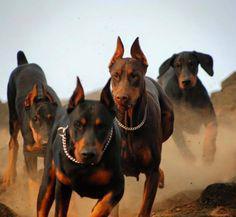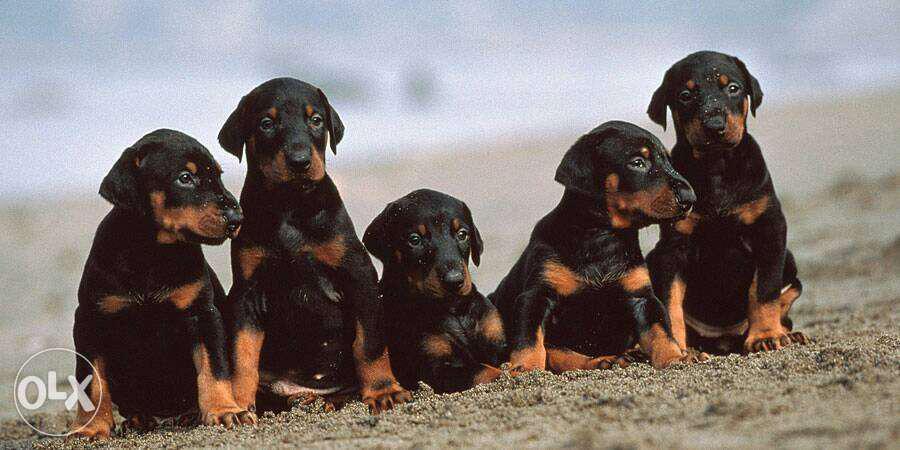The first image is the image on the left, the second image is the image on the right. For the images displayed, is the sentence "The right image contains exactly five dogs." factually correct? Answer yes or no. Yes. The first image is the image on the left, the second image is the image on the right. For the images displayed, is the sentence "All dogs are pointy-eared adult dobermans, and at least seven dogs in total are shown." factually correct? Answer yes or no. No. 